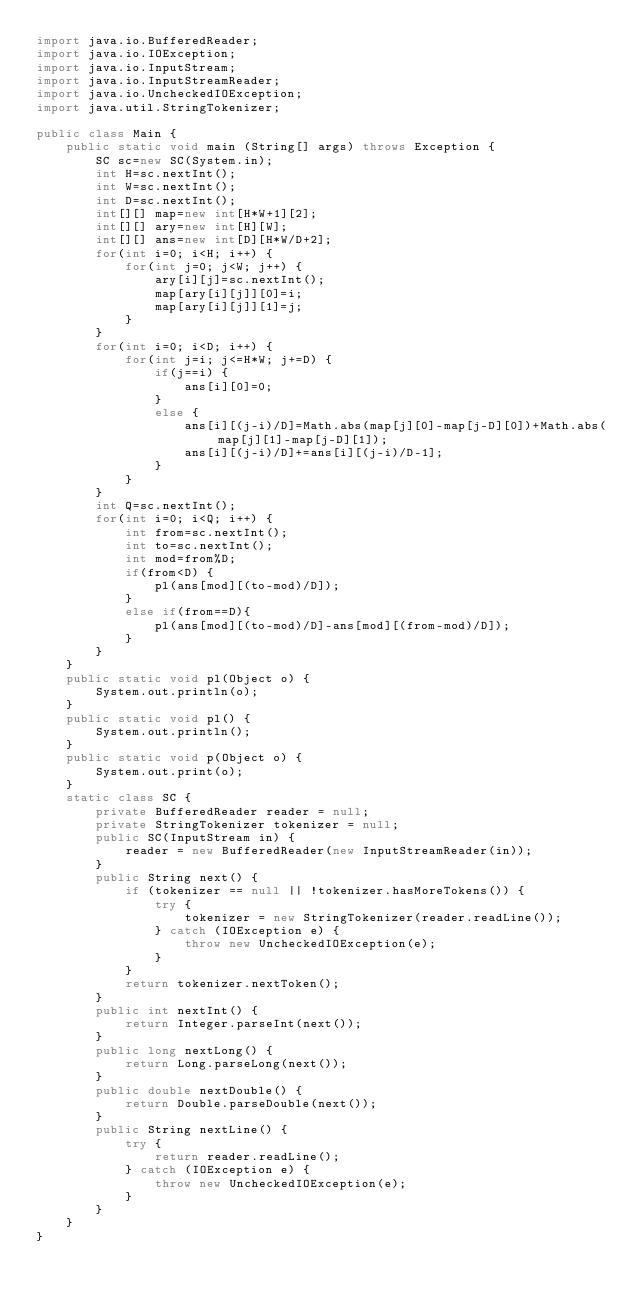Convert code to text. <code><loc_0><loc_0><loc_500><loc_500><_Java_>import java.io.BufferedReader;
import java.io.IOException;
import java.io.InputStream;
import java.io.InputStreamReader;
import java.io.UncheckedIOException;
import java.util.StringTokenizer;

public class Main {
	public static void main (String[] args) throws Exception {
		SC sc=new SC(System.in);
		int H=sc.nextInt();
		int W=sc.nextInt();
		int D=sc.nextInt();
		int[][] map=new int[H*W+1][2];
		int[][] ary=new int[H][W];
		int[][] ans=new int[D][H*W/D+2];
		for(int i=0; i<H; i++) {
			for(int j=0; j<W; j++) {
				ary[i][j]=sc.nextInt();
				map[ary[i][j]][0]=i;
				map[ary[i][j]][1]=j;
			}
		}
		for(int i=0; i<D; i++) {
			for(int j=i; j<=H*W; j+=D) {
				if(j==i) {
					ans[i][0]=0;
				}
				else {
					ans[i][(j-i)/D]=Math.abs(map[j][0]-map[j-D][0])+Math.abs(map[j][1]-map[j-D][1]);
					ans[i][(j-i)/D]+=ans[i][(j-i)/D-1];
				}
			}
		}
		int Q=sc.nextInt();
		for(int i=0; i<Q; i++) {
			int from=sc.nextInt();
			int to=sc.nextInt();
			int mod=from%D;
			if(from<D) {
				pl(ans[mod][(to-mod)/D]);
			}
			else if(from==D){
				pl(ans[mod][(to-mod)/D]-ans[mod][(from-mod)/D]);
			}
		}
	}
	public static void pl(Object o) {
		System.out.println(o);
	}
	public static void pl() {
		System.out.println();
	}
	public static void p(Object o) {
		System.out.print(o);
	}
	static class SC {
		private BufferedReader reader = null;
		private StringTokenizer tokenizer = null;
		public SC(InputStream in) {
			reader = new BufferedReader(new InputStreamReader(in));
		}
		public String next() {
			if (tokenizer == null || !tokenizer.hasMoreTokens()) {
				try {
					tokenizer = new StringTokenizer(reader.readLine());
				} catch (IOException e) {
					throw new UncheckedIOException(e);
				}
			}
			return tokenizer.nextToken();
		}
		public int nextInt() {
			return Integer.parseInt(next());
		}
		public long nextLong() {
			return Long.parseLong(next());
		}
		public double nextDouble() {
			return Double.parseDouble(next());
		}
		public String nextLine() {
			try {
				return reader.readLine();
			} catch (IOException e) {
				throw new UncheckedIOException(e);
			}
		}
	}
}</code> 